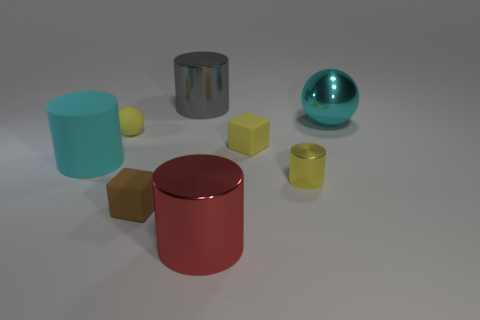Add 1 large red metal objects. How many objects exist? 9 Subtract all cubes. How many objects are left? 6 Subtract all green rubber objects. Subtract all balls. How many objects are left? 6 Add 3 tiny yellow balls. How many tiny yellow balls are left? 4 Add 4 tiny purple objects. How many tiny purple objects exist? 4 Subtract 0 purple balls. How many objects are left? 8 